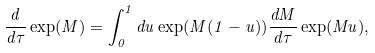<formula> <loc_0><loc_0><loc_500><loc_500>\frac { d } { d \tau } \exp ( M ) = \int _ { 0 } ^ { 1 } d u \exp ( M ( 1 - u ) ) \frac { d M } { d \tau } \exp ( M u ) ,</formula> 